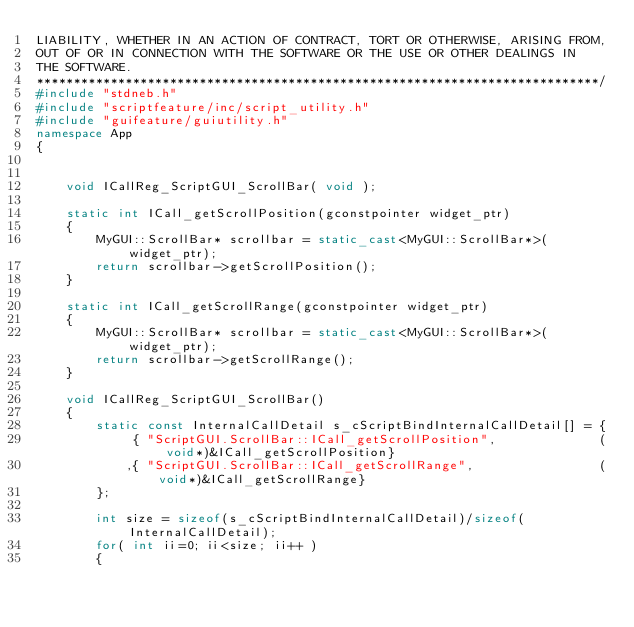Convert code to text. <code><loc_0><loc_0><loc_500><loc_500><_C++_>LIABILITY, WHETHER IN AN ACTION OF CONTRACT, TORT OR OTHERWISE, ARISING FROM,
OUT OF OR IN CONNECTION WITH THE SOFTWARE OR THE USE OR OTHER DEALINGS IN
THE SOFTWARE.
****************************************************************************/
#include "stdneb.h"
#include "scriptfeature/inc/script_utility.h"
#include "guifeature/guiutility.h"
namespace App
{


	void ICallReg_ScriptGUI_ScrollBar( void );

	static int ICall_getScrollPosition(gconstpointer widget_ptr)
	{
		MyGUI::ScrollBar* scrollbar = static_cast<MyGUI::ScrollBar*>(widget_ptr);
		return scrollbar->getScrollPosition();
	}
	
	static int ICall_getScrollRange(gconstpointer widget_ptr)
	{
		MyGUI::ScrollBar* scrollbar = static_cast<MyGUI::ScrollBar*>(widget_ptr);
		return scrollbar->getScrollRange();
	}

	void ICallReg_ScriptGUI_ScrollBar()
	{
		static const InternalCallDetail s_cScriptBindInternalCallDetail[] = {
			 { "ScriptGUI.ScrollBar::ICall_getScrollPosition",				(void*)&ICall_getScrollPosition}
			,{ "ScriptGUI.ScrollBar::ICall_getScrollRange",					(void*)&ICall_getScrollRange}
		};

		int size = sizeof(s_cScriptBindInternalCallDetail)/sizeof(InternalCallDetail);
		for( int ii=0; ii<size; ii++ )
		{</code> 